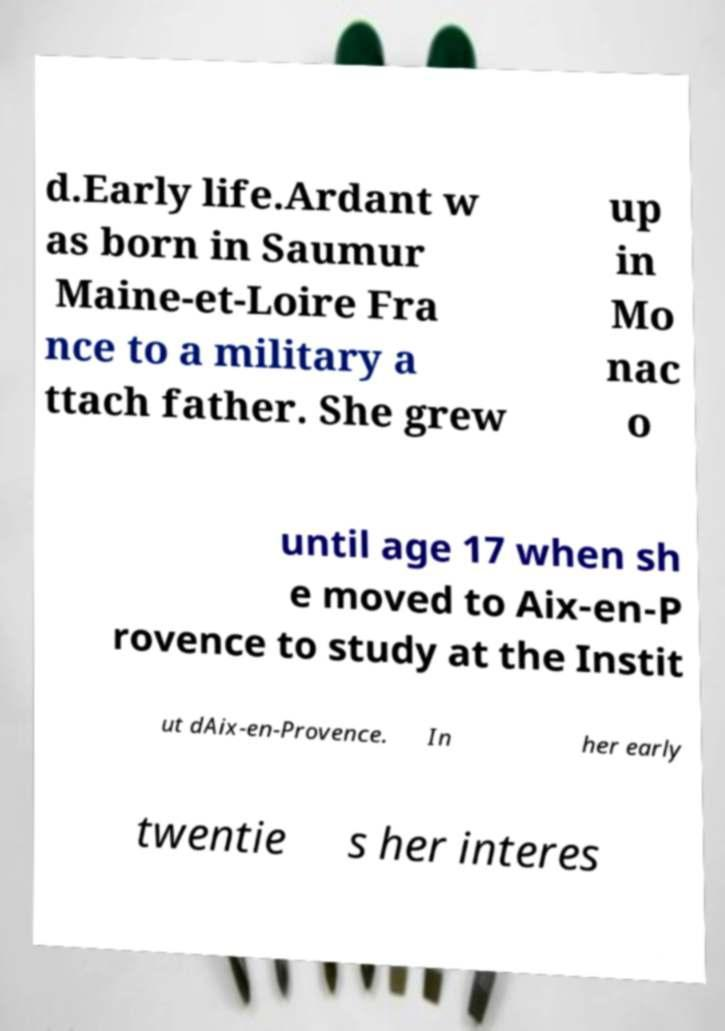For documentation purposes, I need the text within this image transcribed. Could you provide that? d.Early life.Ardant w as born in Saumur Maine-et-Loire Fra nce to a military a ttach father. She grew up in Mo nac o until age 17 when sh e moved to Aix-en-P rovence to study at the Instit ut dAix-en-Provence. In her early twentie s her interes 